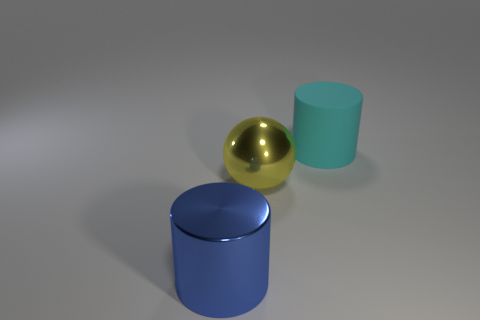Is there any other thing that is the same material as the cyan cylinder?
Ensure brevity in your answer.  No. There is a thing that is right of the blue cylinder and on the left side of the cyan rubber object; what is its shape?
Your answer should be compact. Sphere. How many tiny things are either shiny cylinders or red matte cubes?
Offer a very short reply. 0. Are there the same number of matte things that are in front of the cyan thing and big shiny objects that are in front of the big sphere?
Your answer should be compact. No. Is the number of yellow things that are to the left of the shiny cylinder the same as the number of purple rubber cubes?
Give a very brief answer. Yes. Is the blue metallic object the same size as the cyan cylinder?
Your answer should be very brief. Yes. The large object that is on the right side of the big blue cylinder and in front of the large rubber cylinder is made of what material?
Your answer should be compact. Metal. How many other objects are the same shape as the big cyan object?
Provide a short and direct response. 1. What material is the large cylinder that is in front of the large cyan rubber cylinder?
Keep it short and to the point. Metal. Are there fewer rubber cylinders that are to the right of the large cyan thing than blue spheres?
Your response must be concise. No. 